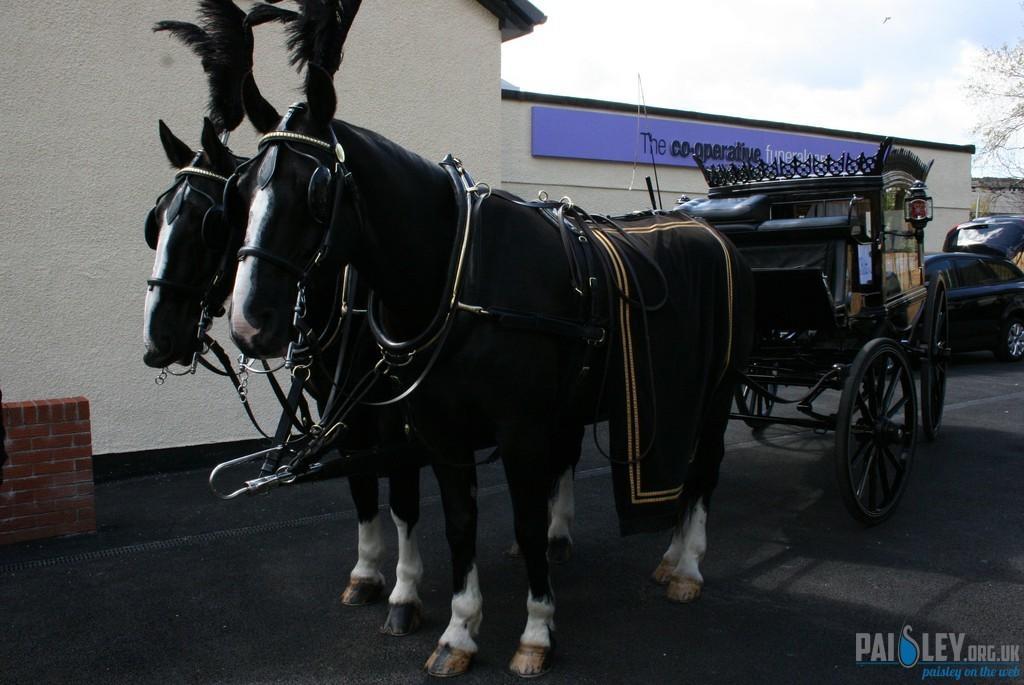How would you summarize this image in a sentence or two? In this picture I can see a chariot and couple of cars in the back and I can see a building and a board with some text. I can see text at the bottom right corner of the picture. I can see a tree and a blue cloudy sky and It looks like a compound wall on the left side. 